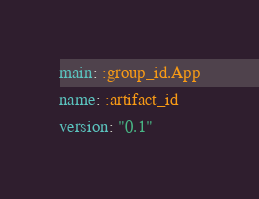Convert code to text. <code><loc_0><loc_0><loc_500><loc_500><_YAML_>main: :group_id.App
name: :artifact_id
version: "0.1"
</code> 